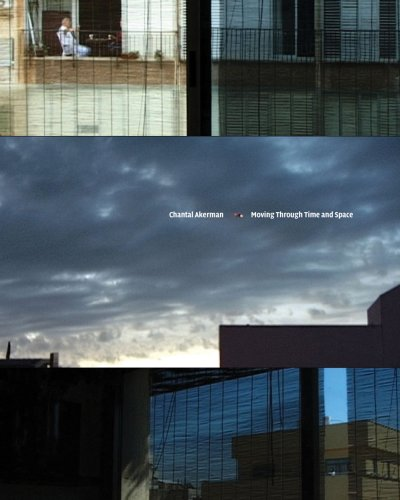Is this a religious book? No, this book is centered on arts and film, particularly focusing on Chantal Akerman's innovative contributions to these fields rather than any religious themes. 